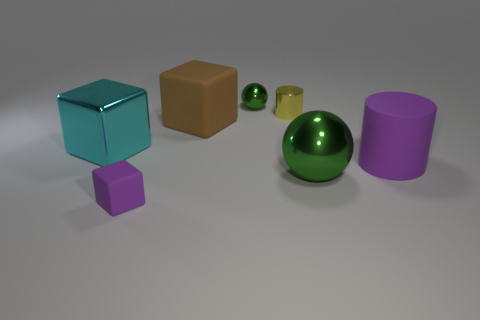How does the lighting in the image affect the mood or atmosphere? The soft, diffused lighting in the image creates a calm and tranquil atmosphere. The gentle shadows and subtle reflections contribute to a composed, almost minimalist aesthetic, enhancing the perception of each object's shape and texture without harsh contrasts. 